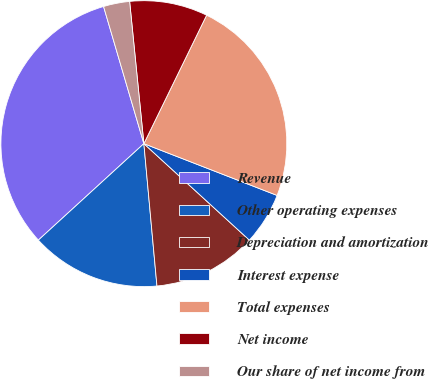<chart> <loc_0><loc_0><loc_500><loc_500><pie_chart><fcel>Revenue<fcel>Other operating expenses<fcel>Depreciation and amortization<fcel>Interest expense<fcel>Total expenses<fcel>Net income<fcel>Our share of net income from<nl><fcel>32.24%<fcel>14.67%<fcel>11.75%<fcel>5.89%<fcel>23.67%<fcel>8.82%<fcel>2.96%<nl></chart> 